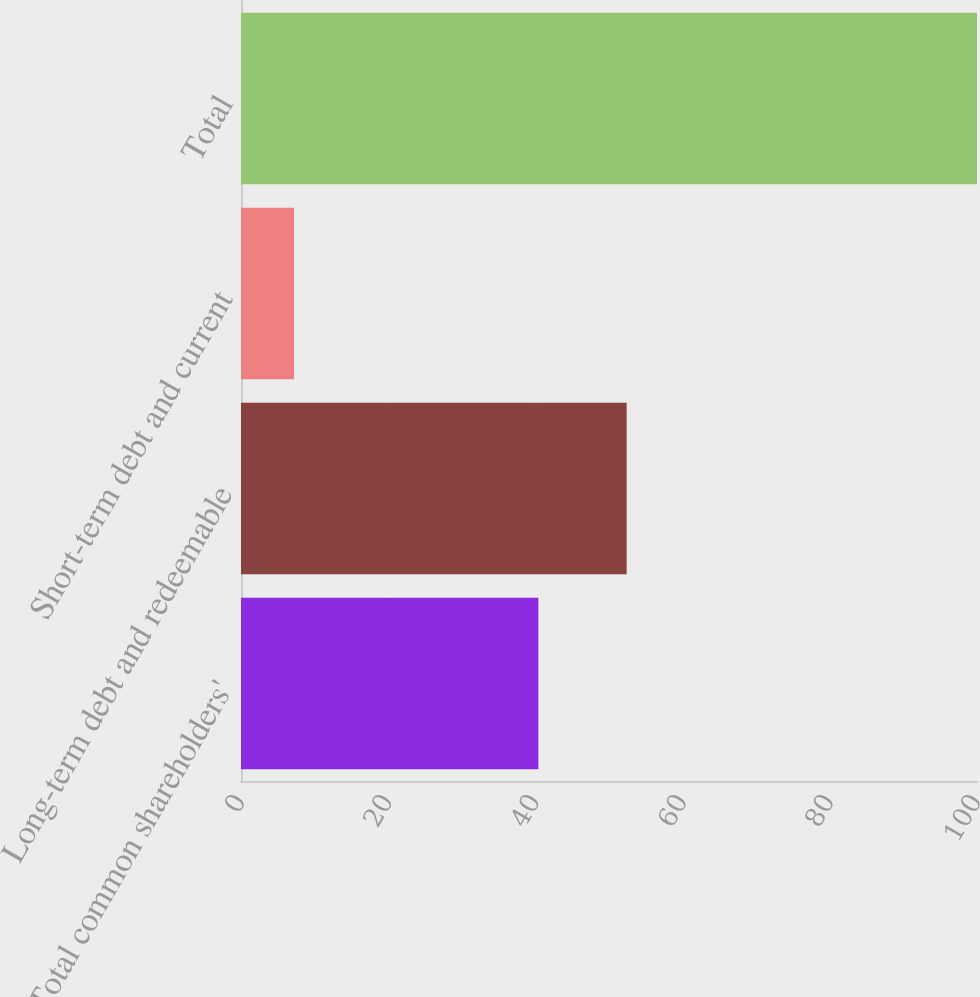Convert chart to OTSL. <chart><loc_0><loc_0><loc_500><loc_500><bar_chart><fcel>Total common shareholders'<fcel>Long-term debt and redeemable<fcel>Short-term debt and current<fcel>Total<nl><fcel>40.4<fcel>52.4<fcel>7.2<fcel>100<nl></chart> 